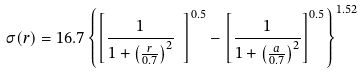Convert formula to latex. <formula><loc_0><loc_0><loc_500><loc_500>\sigma ( r ) = 1 6 . 7 \left \{ \left [ \frac { 1 } { 1 + \left ( \frac { r } { 0 . 7 } \right ) ^ { 2 } } \ \right ] ^ { 0 . 5 } - \left [ \frac { 1 } { 1 + \left ( \frac { a } { 0 . 7 } \right ) ^ { 2 } } \right ] ^ { 0 . 5 } \right \} ^ { 1 . 5 2 }</formula> 